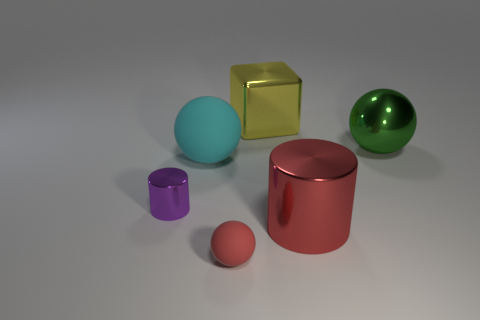Are there any other things that have the same size as the metal ball?
Offer a very short reply. Yes. What is the size of the thing that is the same color as the large metal cylinder?
Provide a succinct answer. Small. There is a cyan matte object that is the same shape as the large green shiny thing; what size is it?
Make the answer very short. Large. Are there fewer cyan rubber things that are to the right of the small purple cylinder than blue matte cylinders?
Provide a short and direct response. No. Are there any large metal objects?
Make the answer very short. Yes. What color is the big thing that is the same shape as the tiny shiny object?
Offer a terse response. Red. Is the color of the metallic cylinder that is behind the large red object the same as the big metal cylinder?
Offer a terse response. No. Is the size of the cyan sphere the same as the yellow shiny cube?
Your answer should be compact. Yes. There is a tiny purple thing that is made of the same material as the large yellow object; what is its shape?
Give a very brief answer. Cylinder. How many other things are the same shape as the purple thing?
Your answer should be very brief. 1. 